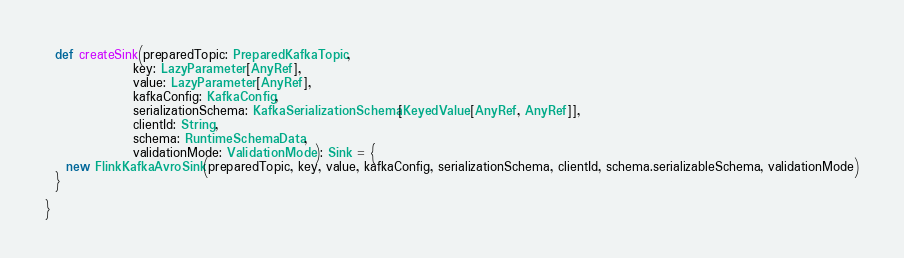Convert code to text. <code><loc_0><loc_0><loc_500><loc_500><_Scala_>  def createSink(preparedTopic: PreparedKafkaTopic,
                 key: LazyParameter[AnyRef],
                 value: LazyParameter[AnyRef],
                 kafkaConfig: KafkaConfig,
                 serializationSchema: KafkaSerializationSchema[KeyedValue[AnyRef, AnyRef]],
                 clientId: String,
                 schema: RuntimeSchemaData,
                 validationMode: ValidationMode): Sink = {
    new FlinkKafkaAvroSink(preparedTopic, key, value, kafkaConfig, serializationSchema, clientId, schema.serializableSchema, validationMode)
  }

}
</code> 